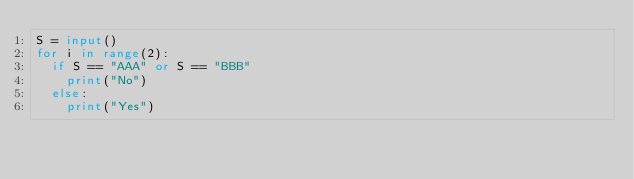<code> <loc_0><loc_0><loc_500><loc_500><_Python_>S = input()
for i in range(2):
  if S == "AAA" or S == "BBB"
    print("No")
  else:
    print("Yes")</code> 